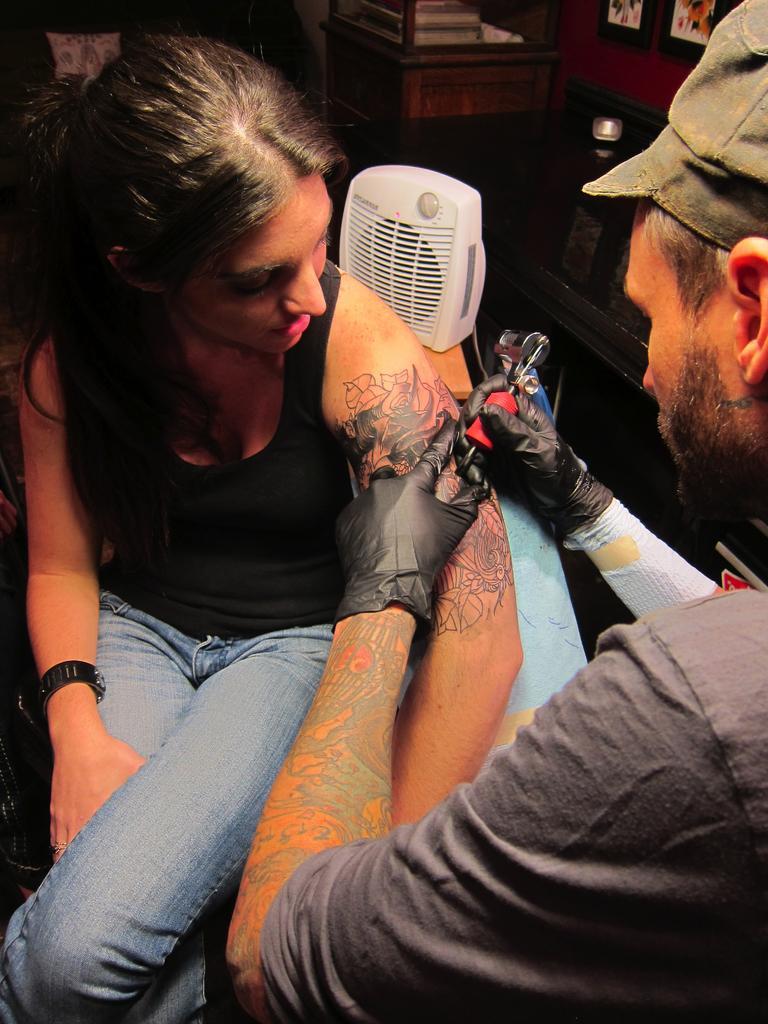Please provide a concise description of this image. There are 2 people in a room. A woman is sitting wearing a black vest and jeans. A man is present on the right and he is making a tattoo on the girl's hand. There is a white cooler at the back and there are photo frames on the wall. 